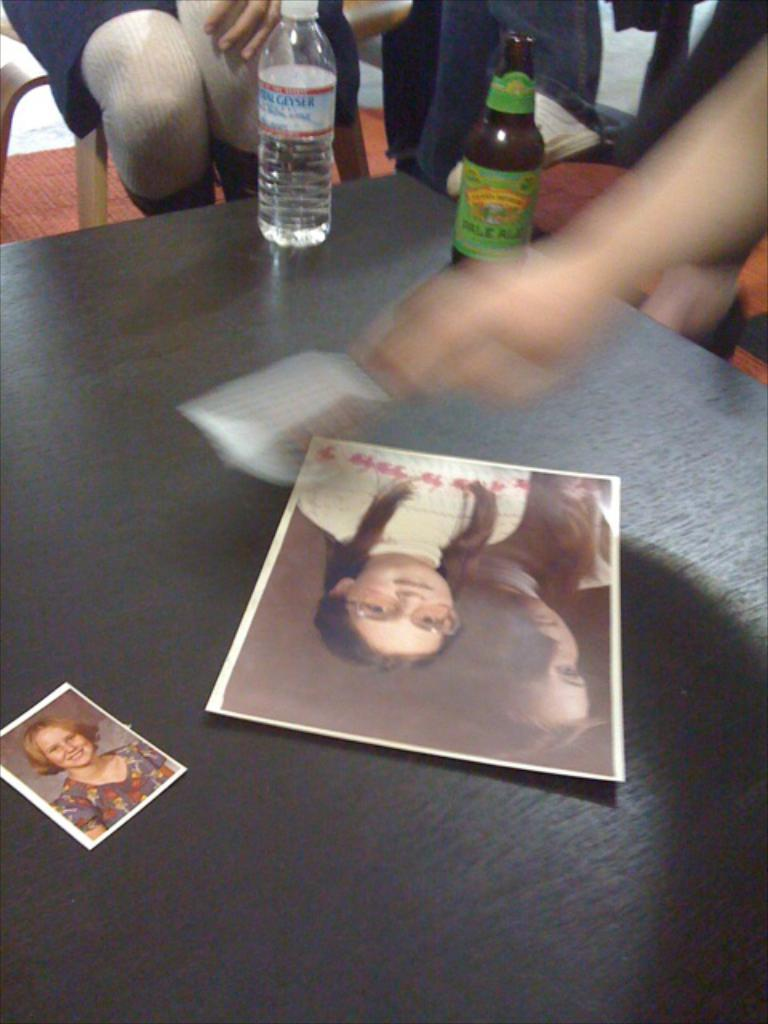What piece of furniture is present in the image? There is a table in the image. What is placed on the table? There are photos and a bottle on the table. Are there any people in the image? Yes, there are people sitting on chairs near the table. Can you see any ghosts interacting with the people in the image? There are no ghosts present in the image. What type of base is supporting the table in the image? The image does not provide information about the base of the table. 